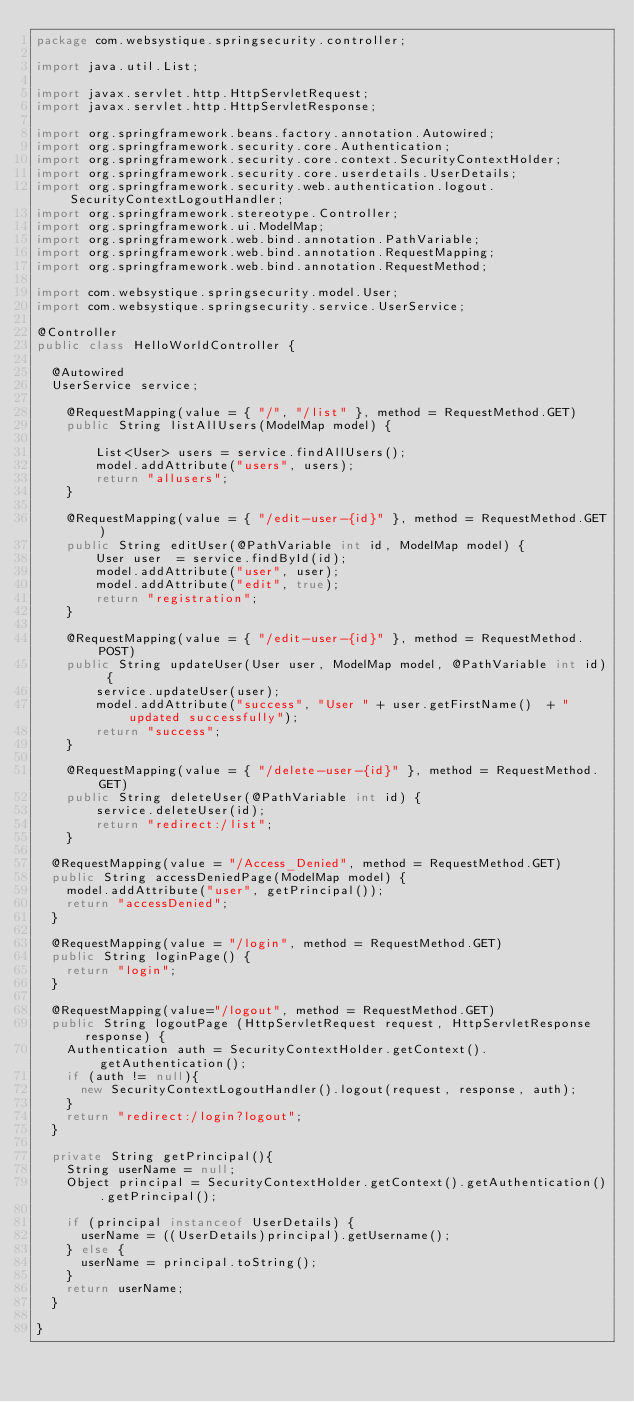<code> <loc_0><loc_0><loc_500><loc_500><_Java_>package com.websystique.springsecurity.controller;

import java.util.List;

import javax.servlet.http.HttpServletRequest;
import javax.servlet.http.HttpServletResponse;

import org.springframework.beans.factory.annotation.Autowired;
import org.springframework.security.core.Authentication;
import org.springframework.security.core.context.SecurityContextHolder;
import org.springframework.security.core.userdetails.UserDetails;
import org.springframework.security.web.authentication.logout.SecurityContextLogoutHandler;
import org.springframework.stereotype.Controller;
import org.springframework.ui.ModelMap;
import org.springframework.web.bind.annotation.PathVariable;
import org.springframework.web.bind.annotation.RequestMapping;
import org.springframework.web.bind.annotation.RequestMethod;

import com.websystique.springsecurity.model.User;
import com.websystique.springsecurity.service.UserService;

@Controller
public class HelloWorldController {

	@Autowired
	UserService service;
	
    @RequestMapping(value = { "/", "/list" }, method = RequestMethod.GET)
    public String listAllUsers(ModelMap model) {
 
        List<User> users = service.findAllUsers();
        model.addAttribute("users", users);
        return "allusers";
    }
	
    @RequestMapping(value = { "/edit-user-{id}" }, method = RequestMethod.GET)
    public String editUser(@PathVariable int id, ModelMap model) {
        User user  = service.findById(id);
        model.addAttribute("user", user);
        model.addAttribute("edit", true);
        return "registration";
    }
    
    @RequestMapping(value = { "/edit-user-{id}" }, method = RequestMethod.POST)
    public String updateUser(User user, ModelMap model, @PathVariable int id) {
        service.updateUser(user);
        model.addAttribute("success", "User " + user.getFirstName()  + " updated successfully");
        return "success";
    }
    
    @RequestMapping(value = { "/delete-user-{id}" }, method = RequestMethod.GET)
    public String deleteUser(@PathVariable int id) {
        service.deleteUser(id);
        return "redirect:/list";
    }
    
	@RequestMapping(value = "/Access_Denied", method = RequestMethod.GET)
	public String accessDeniedPage(ModelMap model) {
		model.addAttribute("user", getPrincipal());
		return "accessDenied";
	}

	@RequestMapping(value = "/login", method = RequestMethod.GET)
	public String loginPage() {
		return "login";
	}

	@RequestMapping(value="/logout", method = RequestMethod.GET)
	public String logoutPage (HttpServletRequest request, HttpServletResponse response) {
		Authentication auth = SecurityContextHolder.getContext().getAuthentication();
		if (auth != null){    
			new SecurityContextLogoutHandler().logout(request, response, auth);
		}
		return "redirect:/login?logout";
	}

	private String getPrincipal(){
		String userName = null;
		Object principal = SecurityContextHolder.getContext().getAuthentication().getPrincipal();

		if (principal instanceof UserDetails) {
			userName = ((UserDetails)principal).getUsername();
		} else {
			userName = principal.toString();
		}
		return userName;
	}

}</code> 